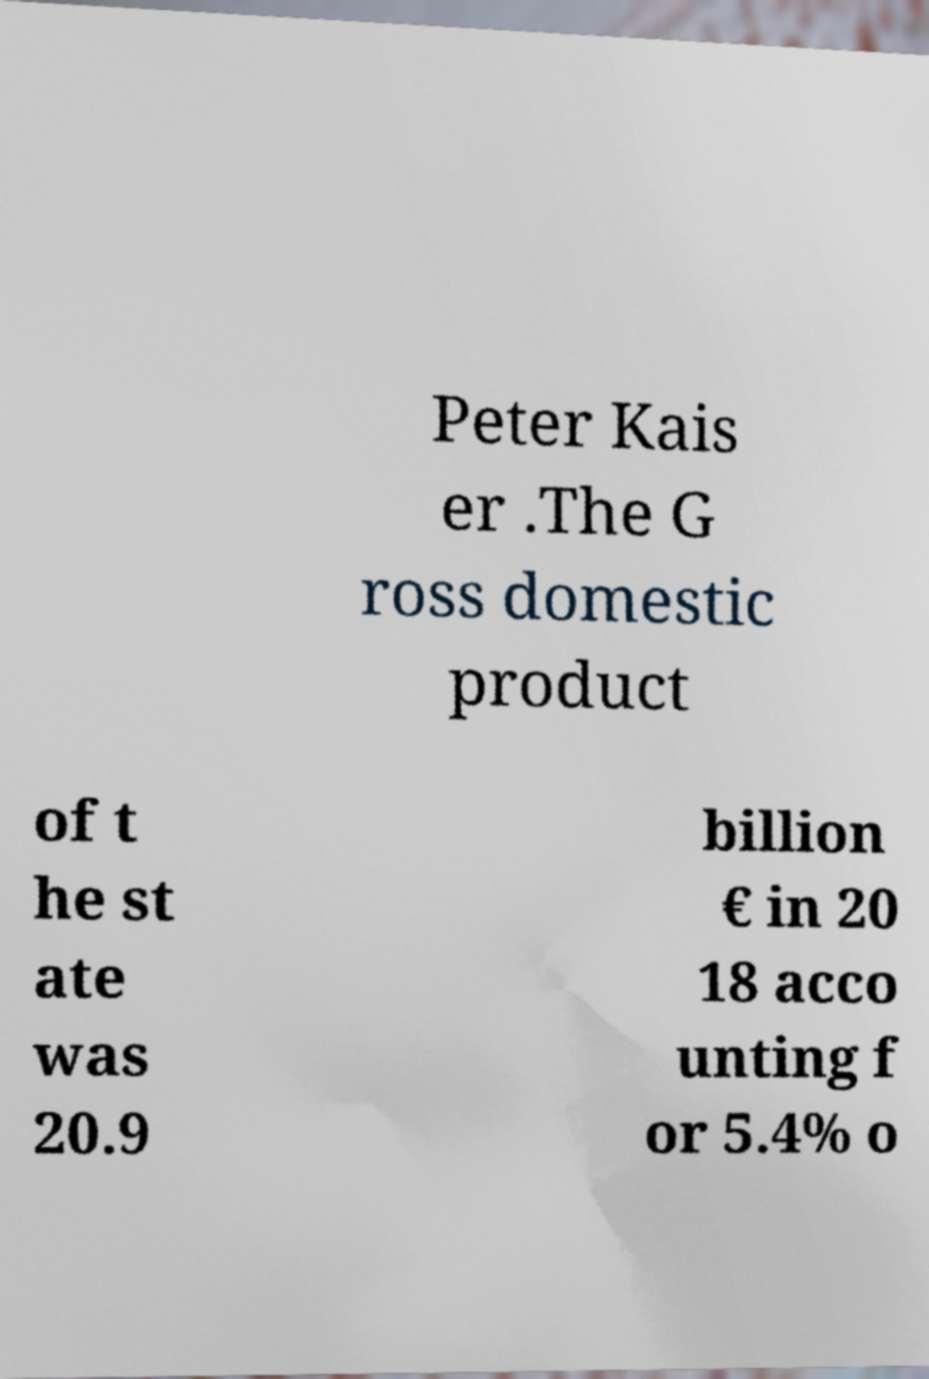For documentation purposes, I need the text within this image transcribed. Could you provide that? Peter Kais er .The G ross domestic product of t he st ate was 20.9 billion € in 20 18 acco unting f or 5.4% o 